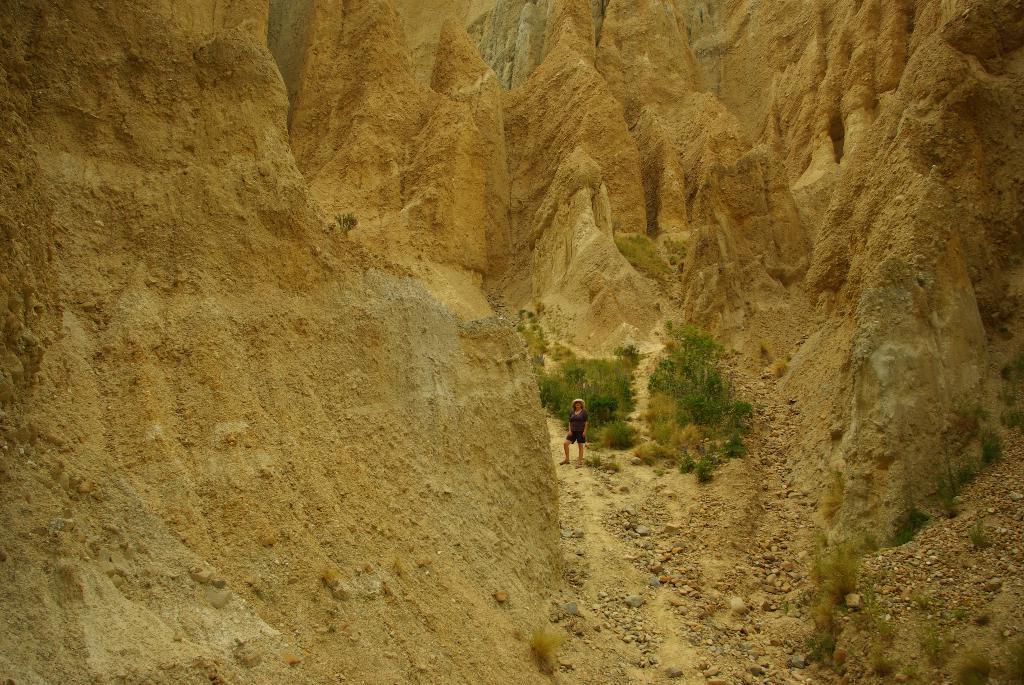Please provide a concise description of this image. In this image I can see few mountains, trees, small stones, sand and one person is standing. 